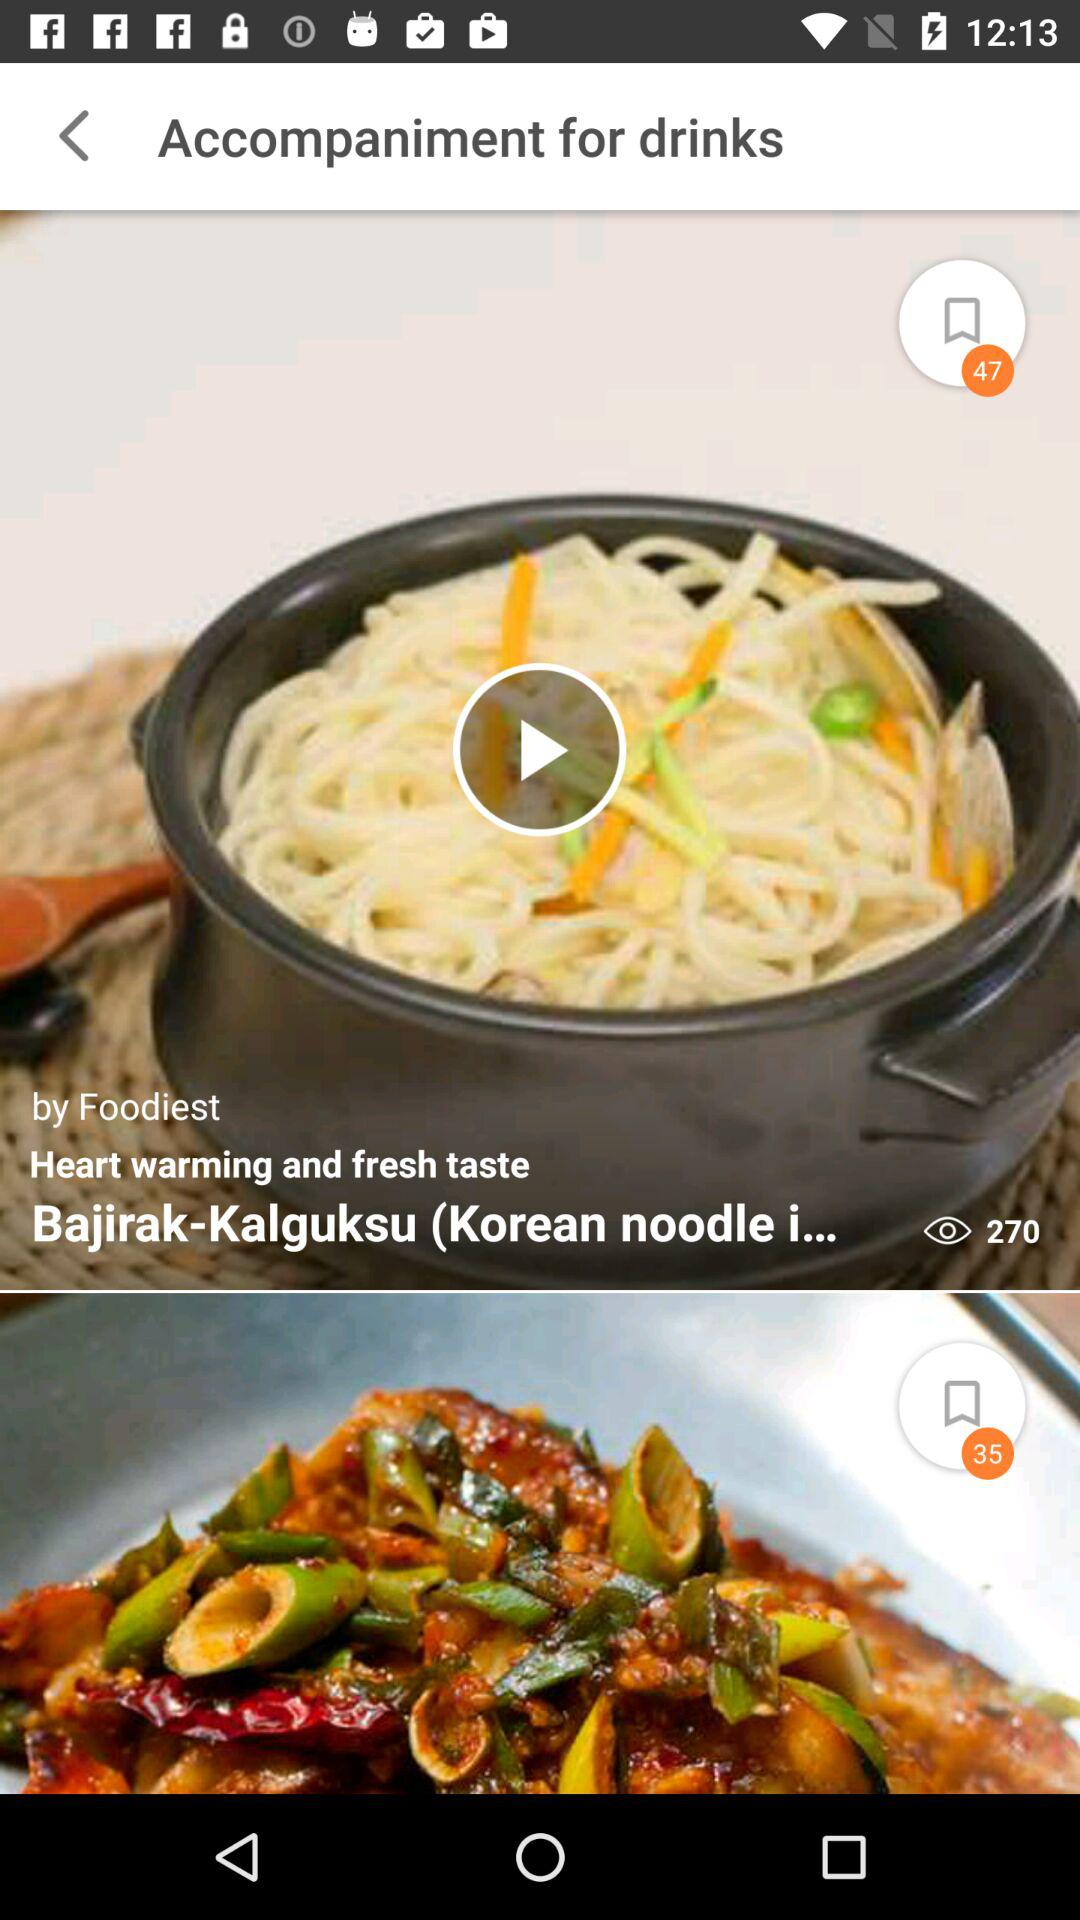How many items are in the Accompaniment for drinks section?
Answer the question using a single word or phrase. 2 